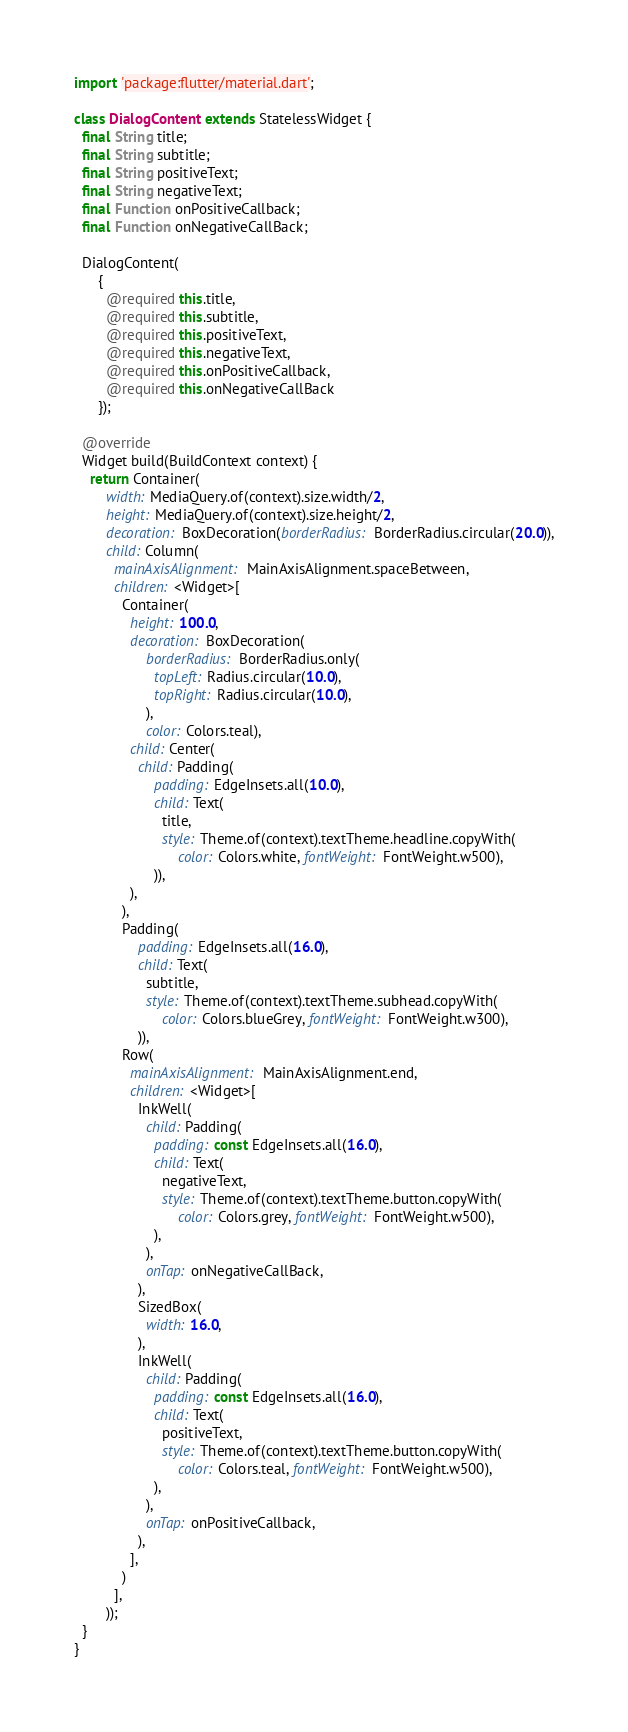<code> <loc_0><loc_0><loc_500><loc_500><_Dart_>import 'package:flutter/material.dart';

class DialogContent extends StatelessWidget {
  final String title;
  final String subtitle;
  final String positiveText;
  final String negativeText;
  final Function onPositiveCallback;
  final Function onNegativeCallBack;

  DialogContent(
      {
        @required this.title,
        @required this.subtitle,
        @required this.positiveText,
        @required this.negativeText,
        @required this.onPositiveCallback,
        @required this.onNegativeCallBack
      });

  @override
  Widget build(BuildContext context) {
    return Container(
        width: MediaQuery.of(context).size.width/2,
        height: MediaQuery.of(context).size.height/2,
        decoration: BoxDecoration(borderRadius: BorderRadius.circular(20.0)),
        child: Column(
          mainAxisAlignment: MainAxisAlignment.spaceBetween,
          children: <Widget>[
            Container(
              height: 100.0,
              decoration: BoxDecoration(
                  borderRadius: BorderRadius.only(
                    topLeft: Radius.circular(10.0),
                    topRight: Radius.circular(10.0),
                  ),
                  color: Colors.teal),
              child: Center(
                child: Padding(
                    padding: EdgeInsets.all(10.0),
                    child: Text(
                      title,
                      style: Theme.of(context).textTheme.headline.copyWith(
                          color: Colors.white, fontWeight: FontWeight.w500),
                    )),
              ),
            ),
            Padding(
                padding: EdgeInsets.all(16.0),
                child: Text(
                  subtitle,
                  style: Theme.of(context).textTheme.subhead.copyWith(
                      color: Colors.blueGrey, fontWeight: FontWeight.w300),
                )),
            Row(
              mainAxisAlignment: MainAxisAlignment.end,
              children: <Widget>[
                InkWell(
                  child: Padding(
                    padding: const EdgeInsets.all(16.0),
                    child: Text(
                      negativeText,
                      style: Theme.of(context).textTheme.button.copyWith(
                          color: Colors.grey, fontWeight: FontWeight.w500),
                    ),
                  ),
                  onTap: onNegativeCallBack,
                ),
                SizedBox(
                  width: 16.0,
                ),
                InkWell(
                  child: Padding(
                    padding: const EdgeInsets.all(16.0),
                    child: Text(
                      positiveText,
                      style: Theme.of(context).textTheme.button.copyWith(
                          color: Colors.teal, fontWeight: FontWeight.w500),
                    ),
                  ),
                  onTap: onPositiveCallback,
                ),
              ],
            )
          ],
        ));
  }
}
</code> 